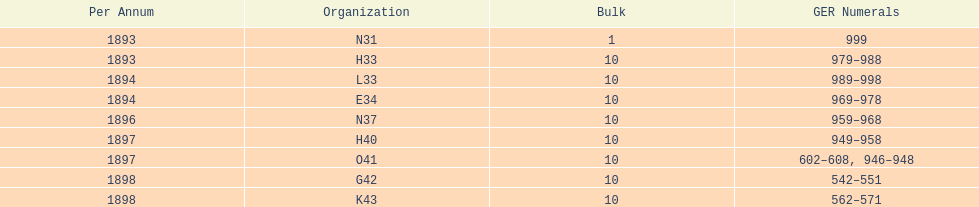What order is listed first at the top of the table? N31. 